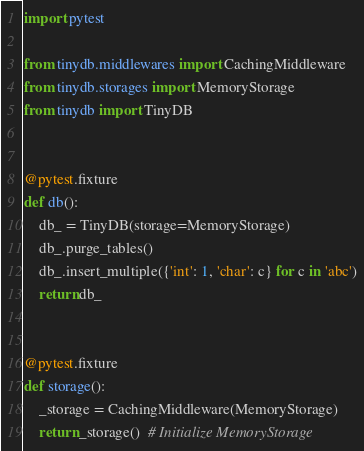Convert code to text. <code><loc_0><loc_0><loc_500><loc_500><_Python_>import pytest

from tinydb.middlewares import CachingMiddleware
from tinydb.storages import MemoryStorage
from tinydb import TinyDB


@pytest.fixture
def db():
    db_ = TinyDB(storage=MemoryStorage)
    db_.purge_tables()
    db_.insert_multiple({'int': 1, 'char': c} for c in 'abc')
    return db_


@pytest.fixture
def storage():
    _storage = CachingMiddleware(MemoryStorage)
    return _storage()  # Initialize MemoryStorage
</code> 